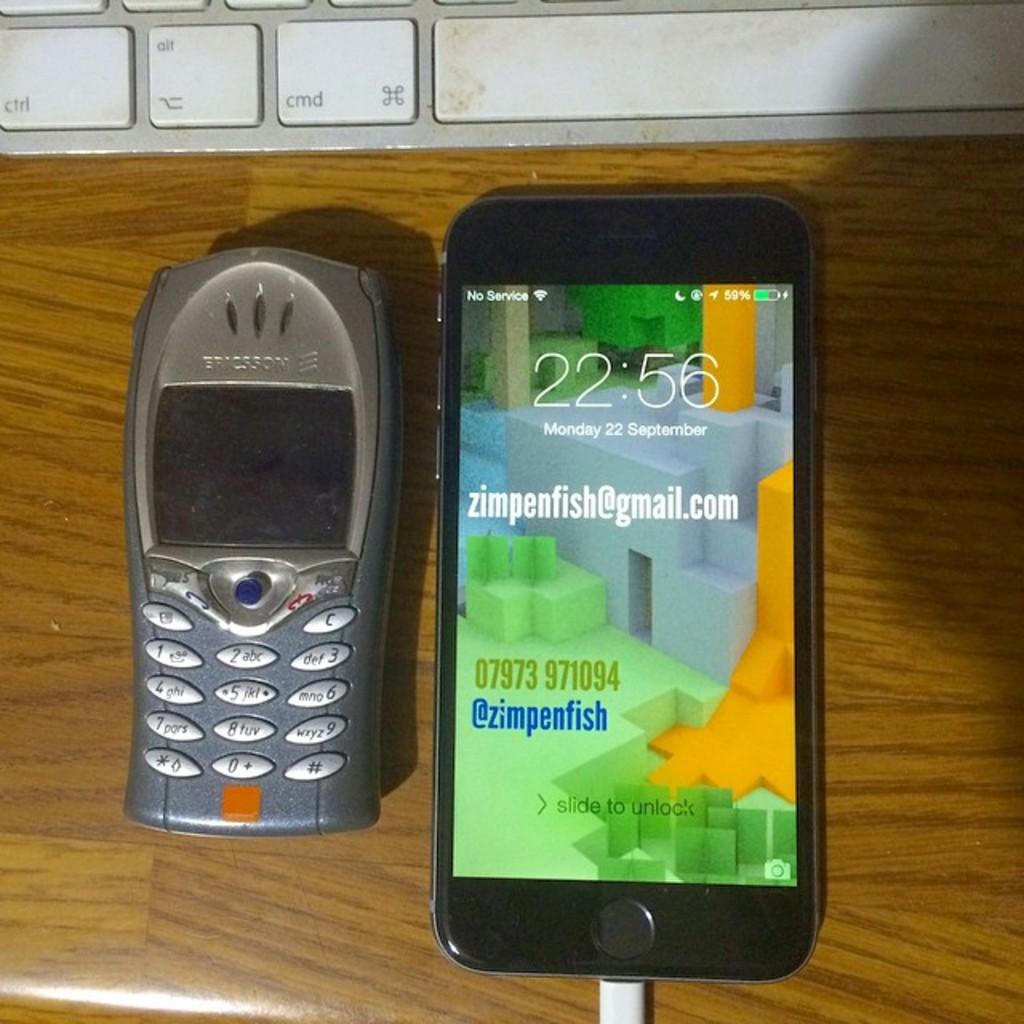Whose email is shown on the phone?
Your answer should be very brief. Zimpenfish. What month is it?
Keep it short and to the point. September. 